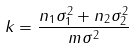Convert formula to latex. <formula><loc_0><loc_0><loc_500><loc_500>k = \frac { n _ { 1 } \sigma _ { 1 } ^ { 2 } + n _ { 2 } \sigma _ { 2 } ^ { 2 } } { m \sigma ^ { 2 } }</formula> 